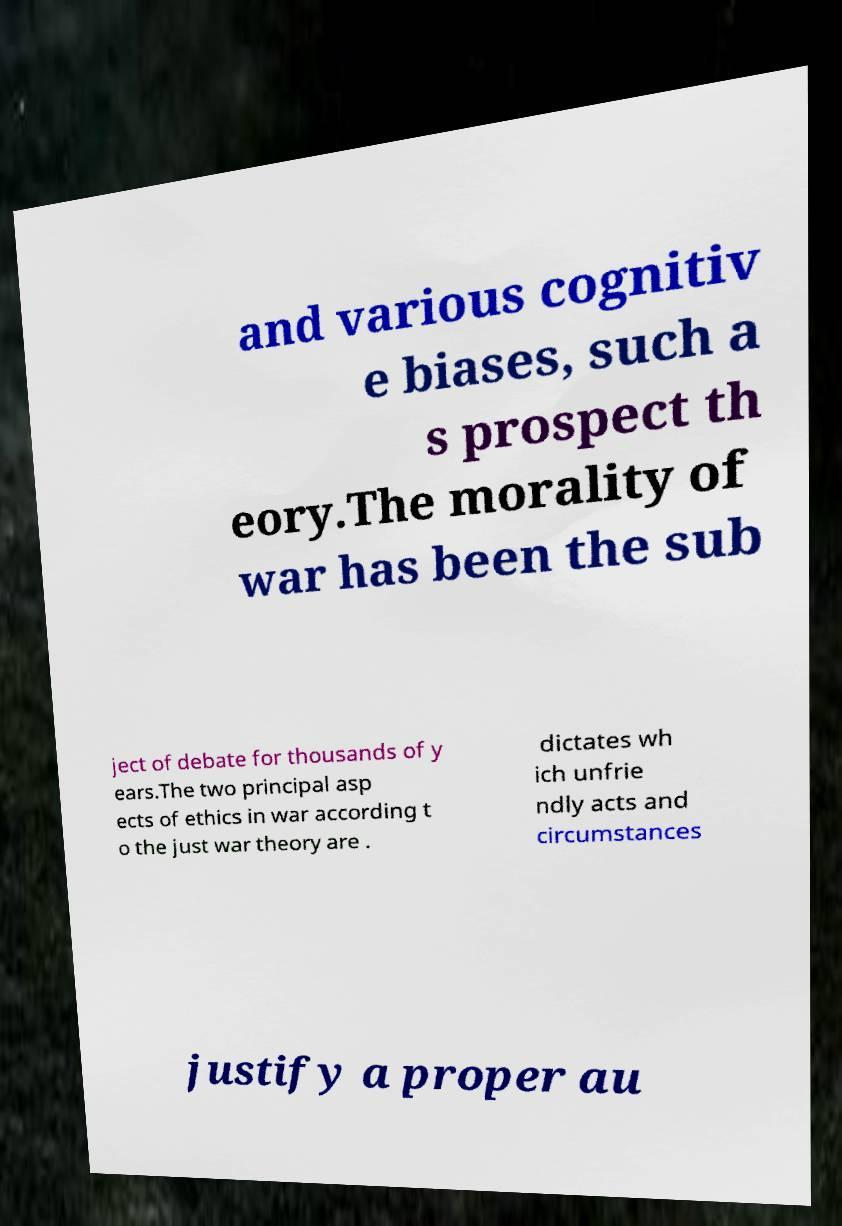Can you accurately transcribe the text from the provided image for me? and various cognitiv e biases, such a s prospect th eory.The morality of war has been the sub ject of debate for thousands of y ears.The two principal asp ects of ethics in war according t o the just war theory are . dictates wh ich unfrie ndly acts and circumstances justify a proper au 